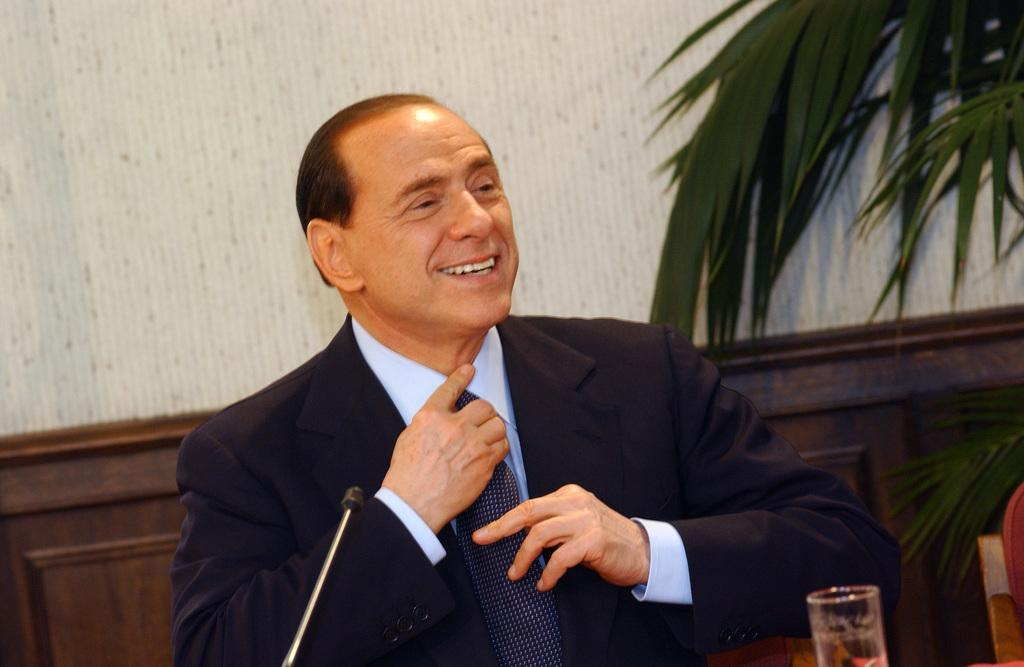Who is the main subject in the foreground of the picture? There is a man in the foreground of the picture. What is the man wearing? The man is wearing black. What is the man doing with his tie? The man is touching his tie. What objects are in front of the man? There is a mic and a glass in front of the man. What can be seen in the background of the picture? There is a wall and a tree in the background of the picture. What type of fowl can be seen perched on the man's shoulder in the image? There is no fowl present on the man's shoulder in the image. What view can be seen from the window in the background of the picture? There is no window visible in the background of the picture. 